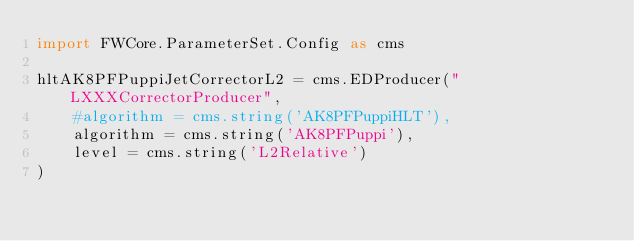<code> <loc_0><loc_0><loc_500><loc_500><_Python_>import FWCore.ParameterSet.Config as cms

hltAK8PFPuppiJetCorrectorL2 = cms.EDProducer("LXXXCorrectorProducer",
    #algorithm = cms.string('AK8PFPuppiHLT'),
    algorithm = cms.string('AK8PFPuppi'),
    level = cms.string('L2Relative')
)
</code> 